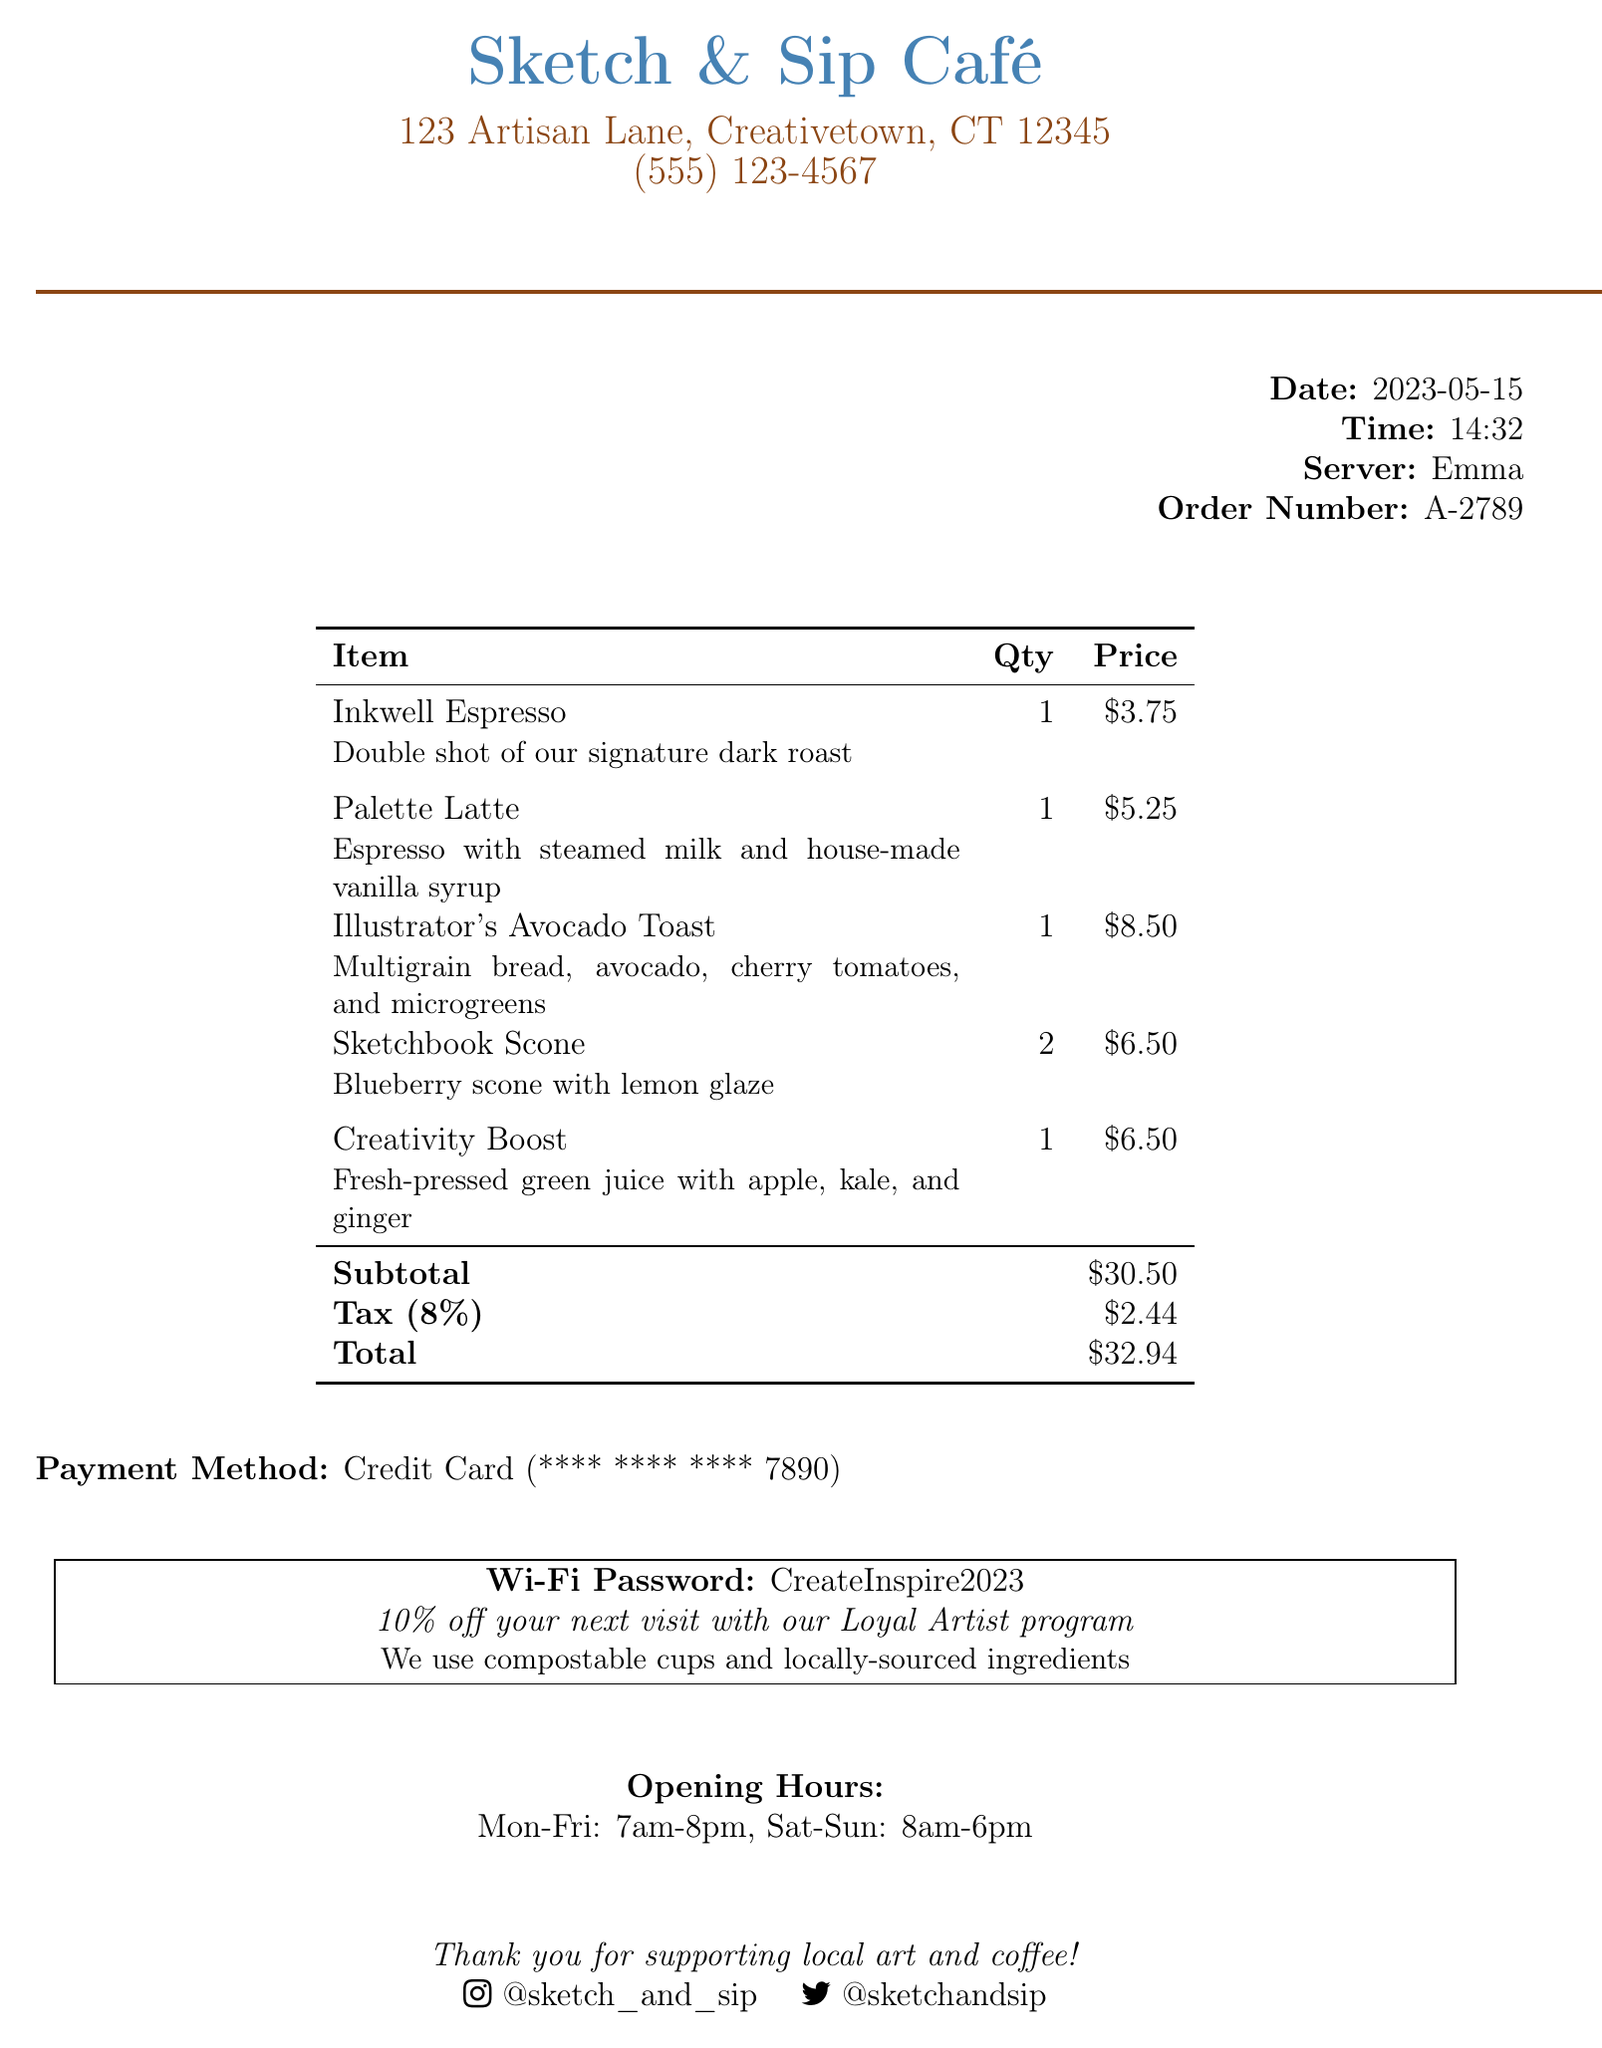what is the name of the café? The café name is provided at the top of the receipt.
Answer: Sketch & Sip Café what is the address of the café? The address is listed below the café name.
Answer: 123 Artisan Lane, Creativetown, CT 12345 what is the date of the transaction? The date is displayed in the transaction information section.
Answer: 2023-05-15 who was the server? The server's name is mentioned in the receipt details.
Answer: Emma what is the total amount spent? The total amount is calculated at the end of the receipt after subtotal and tax.
Answer: $32.94 how many Sketchbook Scones were ordered? The quantity of Sketchbook Scones is listed in the item details table.
Answer: 2 what is the tax rate applied? The tax rate is noted in the pricing information section.
Answer: 8% what promotional offer is mentioned? The promotional offer is included in a special note on the receipt.
Answer: 10% off your next visit with our Loyal Artist program what is the Wi-Fi password? The Wi-Fi password is provided in a designated box on the receipt.
Answer: CreateInspire2023 what are the opening hours of the café? The opening hours are listed at the bottom of the receipt.
Answer: Mon-Fri: 7am-8pm, Sat-Sun: 8am-6pm 